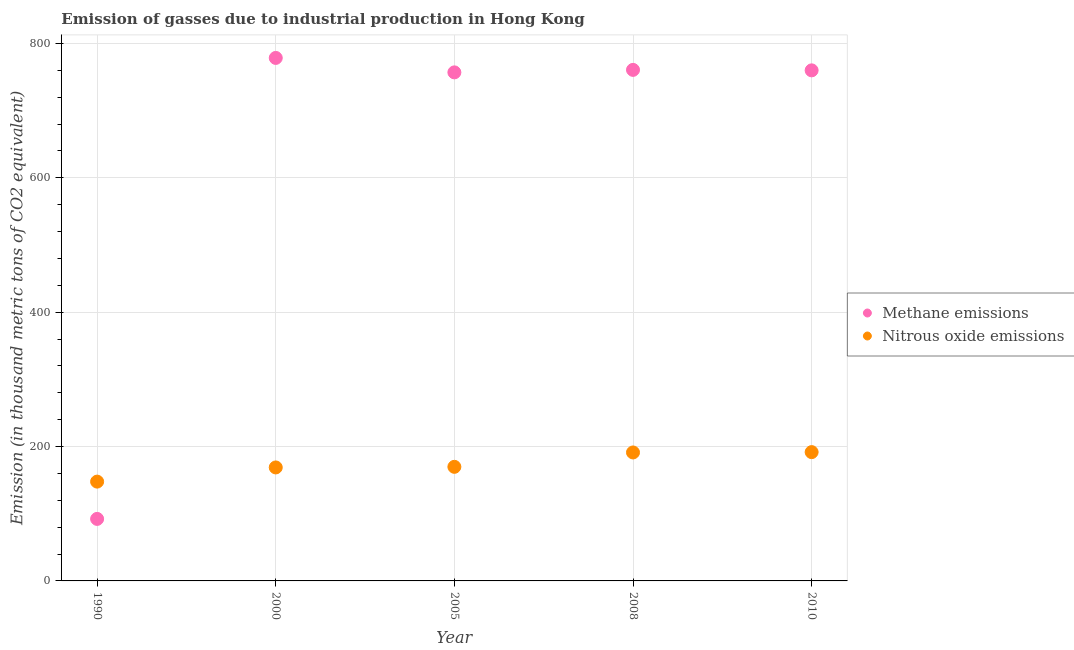What is the amount of nitrous oxide emissions in 2005?
Your answer should be compact. 169.8. Across all years, what is the maximum amount of nitrous oxide emissions?
Keep it short and to the point. 191.7. Across all years, what is the minimum amount of nitrous oxide emissions?
Provide a succinct answer. 147.8. In which year was the amount of nitrous oxide emissions minimum?
Your answer should be very brief. 1990. What is the total amount of nitrous oxide emissions in the graph?
Make the answer very short. 869.4. What is the difference between the amount of methane emissions in 2005 and that in 2010?
Your answer should be compact. -3. What is the difference between the amount of nitrous oxide emissions in 1990 and the amount of methane emissions in 2008?
Keep it short and to the point. -612.8. What is the average amount of methane emissions per year?
Give a very brief answer. 629.62. In the year 2005, what is the difference between the amount of nitrous oxide emissions and amount of methane emissions?
Offer a very short reply. -587.1. What is the ratio of the amount of nitrous oxide emissions in 2005 to that in 2008?
Offer a very short reply. 0.89. Is the difference between the amount of methane emissions in 1990 and 2005 greater than the difference between the amount of nitrous oxide emissions in 1990 and 2005?
Provide a short and direct response. No. What is the difference between the highest and the lowest amount of methane emissions?
Your answer should be very brief. 686.1. In how many years, is the amount of nitrous oxide emissions greater than the average amount of nitrous oxide emissions taken over all years?
Your answer should be compact. 2. Does the amount of nitrous oxide emissions monotonically increase over the years?
Provide a short and direct response. Yes. Is the amount of methane emissions strictly greater than the amount of nitrous oxide emissions over the years?
Keep it short and to the point. No. Is the amount of nitrous oxide emissions strictly less than the amount of methane emissions over the years?
Provide a succinct answer. No. Are the values on the major ticks of Y-axis written in scientific E-notation?
Offer a very short reply. No. Does the graph contain any zero values?
Make the answer very short. No. How many legend labels are there?
Your response must be concise. 2. How are the legend labels stacked?
Make the answer very short. Vertical. What is the title of the graph?
Your response must be concise. Emission of gasses due to industrial production in Hong Kong. Does "Male labourers" appear as one of the legend labels in the graph?
Your response must be concise. No. What is the label or title of the X-axis?
Keep it short and to the point. Year. What is the label or title of the Y-axis?
Your answer should be compact. Emission (in thousand metric tons of CO2 equivalent). What is the Emission (in thousand metric tons of CO2 equivalent) in Methane emissions in 1990?
Offer a very short reply. 92.3. What is the Emission (in thousand metric tons of CO2 equivalent) of Nitrous oxide emissions in 1990?
Your answer should be very brief. 147.8. What is the Emission (in thousand metric tons of CO2 equivalent) of Methane emissions in 2000?
Provide a short and direct response. 778.4. What is the Emission (in thousand metric tons of CO2 equivalent) of Nitrous oxide emissions in 2000?
Your response must be concise. 168.9. What is the Emission (in thousand metric tons of CO2 equivalent) in Methane emissions in 2005?
Offer a terse response. 756.9. What is the Emission (in thousand metric tons of CO2 equivalent) in Nitrous oxide emissions in 2005?
Give a very brief answer. 169.8. What is the Emission (in thousand metric tons of CO2 equivalent) in Methane emissions in 2008?
Keep it short and to the point. 760.6. What is the Emission (in thousand metric tons of CO2 equivalent) in Nitrous oxide emissions in 2008?
Make the answer very short. 191.2. What is the Emission (in thousand metric tons of CO2 equivalent) in Methane emissions in 2010?
Make the answer very short. 759.9. What is the Emission (in thousand metric tons of CO2 equivalent) in Nitrous oxide emissions in 2010?
Make the answer very short. 191.7. Across all years, what is the maximum Emission (in thousand metric tons of CO2 equivalent) of Methane emissions?
Your answer should be compact. 778.4. Across all years, what is the maximum Emission (in thousand metric tons of CO2 equivalent) of Nitrous oxide emissions?
Give a very brief answer. 191.7. Across all years, what is the minimum Emission (in thousand metric tons of CO2 equivalent) in Methane emissions?
Give a very brief answer. 92.3. Across all years, what is the minimum Emission (in thousand metric tons of CO2 equivalent) of Nitrous oxide emissions?
Offer a terse response. 147.8. What is the total Emission (in thousand metric tons of CO2 equivalent) in Methane emissions in the graph?
Your answer should be very brief. 3148.1. What is the total Emission (in thousand metric tons of CO2 equivalent) in Nitrous oxide emissions in the graph?
Ensure brevity in your answer.  869.4. What is the difference between the Emission (in thousand metric tons of CO2 equivalent) of Methane emissions in 1990 and that in 2000?
Keep it short and to the point. -686.1. What is the difference between the Emission (in thousand metric tons of CO2 equivalent) of Nitrous oxide emissions in 1990 and that in 2000?
Offer a terse response. -21.1. What is the difference between the Emission (in thousand metric tons of CO2 equivalent) in Methane emissions in 1990 and that in 2005?
Offer a very short reply. -664.6. What is the difference between the Emission (in thousand metric tons of CO2 equivalent) in Methane emissions in 1990 and that in 2008?
Provide a short and direct response. -668.3. What is the difference between the Emission (in thousand metric tons of CO2 equivalent) in Nitrous oxide emissions in 1990 and that in 2008?
Keep it short and to the point. -43.4. What is the difference between the Emission (in thousand metric tons of CO2 equivalent) in Methane emissions in 1990 and that in 2010?
Your answer should be very brief. -667.6. What is the difference between the Emission (in thousand metric tons of CO2 equivalent) of Nitrous oxide emissions in 1990 and that in 2010?
Offer a very short reply. -43.9. What is the difference between the Emission (in thousand metric tons of CO2 equivalent) in Nitrous oxide emissions in 2000 and that in 2005?
Offer a very short reply. -0.9. What is the difference between the Emission (in thousand metric tons of CO2 equivalent) in Nitrous oxide emissions in 2000 and that in 2008?
Keep it short and to the point. -22.3. What is the difference between the Emission (in thousand metric tons of CO2 equivalent) in Methane emissions in 2000 and that in 2010?
Keep it short and to the point. 18.5. What is the difference between the Emission (in thousand metric tons of CO2 equivalent) of Nitrous oxide emissions in 2000 and that in 2010?
Make the answer very short. -22.8. What is the difference between the Emission (in thousand metric tons of CO2 equivalent) of Nitrous oxide emissions in 2005 and that in 2008?
Ensure brevity in your answer.  -21.4. What is the difference between the Emission (in thousand metric tons of CO2 equivalent) in Methane emissions in 2005 and that in 2010?
Provide a succinct answer. -3. What is the difference between the Emission (in thousand metric tons of CO2 equivalent) of Nitrous oxide emissions in 2005 and that in 2010?
Your answer should be compact. -21.9. What is the difference between the Emission (in thousand metric tons of CO2 equivalent) in Nitrous oxide emissions in 2008 and that in 2010?
Provide a short and direct response. -0.5. What is the difference between the Emission (in thousand metric tons of CO2 equivalent) in Methane emissions in 1990 and the Emission (in thousand metric tons of CO2 equivalent) in Nitrous oxide emissions in 2000?
Your answer should be very brief. -76.6. What is the difference between the Emission (in thousand metric tons of CO2 equivalent) in Methane emissions in 1990 and the Emission (in thousand metric tons of CO2 equivalent) in Nitrous oxide emissions in 2005?
Your answer should be very brief. -77.5. What is the difference between the Emission (in thousand metric tons of CO2 equivalent) in Methane emissions in 1990 and the Emission (in thousand metric tons of CO2 equivalent) in Nitrous oxide emissions in 2008?
Offer a terse response. -98.9. What is the difference between the Emission (in thousand metric tons of CO2 equivalent) of Methane emissions in 1990 and the Emission (in thousand metric tons of CO2 equivalent) of Nitrous oxide emissions in 2010?
Your response must be concise. -99.4. What is the difference between the Emission (in thousand metric tons of CO2 equivalent) in Methane emissions in 2000 and the Emission (in thousand metric tons of CO2 equivalent) in Nitrous oxide emissions in 2005?
Ensure brevity in your answer.  608.6. What is the difference between the Emission (in thousand metric tons of CO2 equivalent) of Methane emissions in 2000 and the Emission (in thousand metric tons of CO2 equivalent) of Nitrous oxide emissions in 2008?
Offer a very short reply. 587.2. What is the difference between the Emission (in thousand metric tons of CO2 equivalent) of Methane emissions in 2000 and the Emission (in thousand metric tons of CO2 equivalent) of Nitrous oxide emissions in 2010?
Provide a short and direct response. 586.7. What is the difference between the Emission (in thousand metric tons of CO2 equivalent) of Methane emissions in 2005 and the Emission (in thousand metric tons of CO2 equivalent) of Nitrous oxide emissions in 2008?
Offer a very short reply. 565.7. What is the difference between the Emission (in thousand metric tons of CO2 equivalent) in Methane emissions in 2005 and the Emission (in thousand metric tons of CO2 equivalent) in Nitrous oxide emissions in 2010?
Keep it short and to the point. 565.2. What is the difference between the Emission (in thousand metric tons of CO2 equivalent) of Methane emissions in 2008 and the Emission (in thousand metric tons of CO2 equivalent) of Nitrous oxide emissions in 2010?
Make the answer very short. 568.9. What is the average Emission (in thousand metric tons of CO2 equivalent) of Methane emissions per year?
Keep it short and to the point. 629.62. What is the average Emission (in thousand metric tons of CO2 equivalent) in Nitrous oxide emissions per year?
Offer a very short reply. 173.88. In the year 1990, what is the difference between the Emission (in thousand metric tons of CO2 equivalent) of Methane emissions and Emission (in thousand metric tons of CO2 equivalent) of Nitrous oxide emissions?
Your answer should be very brief. -55.5. In the year 2000, what is the difference between the Emission (in thousand metric tons of CO2 equivalent) of Methane emissions and Emission (in thousand metric tons of CO2 equivalent) of Nitrous oxide emissions?
Provide a short and direct response. 609.5. In the year 2005, what is the difference between the Emission (in thousand metric tons of CO2 equivalent) in Methane emissions and Emission (in thousand metric tons of CO2 equivalent) in Nitrous oxide emissions?
Provide a succinct answer. 587.1. In the year 2008, what is the difference between the Emission (in thousand metric tons of CO2 equivalent) of Methane emissions and Emission (in thousand metric tons of CO2 equivalent) of Nitrous oxide emissions?
Provide a short and direct response. 569.4. In the year 2010, what is the difference between the Emission (in thousand metric tons of CO2 equivalent) of Methane emissions and Emission (in thousand metric tons of CO2 equivalent) of Nitrous oxide emissions?
Your answer should be compact. 568.2. What is the ratio of the Emission (in thousand metric tons of CO2 equivalent) of Methane emissions in 1990 to that in 2000?
Provide a succinct answer. 0.12. What is the ratio of the Emission (in thousand metric tons of CO2 equivalent) of Nitrous oxide emissions in 1990 to that in 2000?
Make the answer very short. 0.88. What is the ratio of the Emission (in thousand metric tons of CO2 equivalent) in Methane emissions in 1990 to that in 2005?
Ensure brevity in your answer.  0.12. What is the ratio of the Emission (in thousand metric tons of CO2 equivalent) in Nitrous oxide emissions in 1990 to that in 2005?
Offer a terse response. 0.87. What is the ratio of the Emission (in thousand metric tons of CO2 equivalent) in Methane emissions in 1990 to that in 2008?
Ensure brevity in your answer.  0.12. What is the ratio of the Emission (in thousand metric tons of CO2 equivalent) in Nitrous oxide emissions in 1990 to that in 2008?
Make the answer very short. 0.77. What is the ratio of the Emission (in thousand metric tons of CO2 equivalent) in Methane emissions in 1990 to that in 2010?
Make the answer very short. 0.12. What is the ratio of the Emission (in thousand metric tons of CO2 equivalent) of Nitrous oxide emissions in 1990 to that in 2010?
Ensure brevity in your answer.  0.77. What is the ratio of the Emission (in thousand metric tons of CO2 equivalent) in Methane emissions in 2000 to that in 2005?
Keep it short and to the point. 1.03. What is the ratio of the Emission (in thousand metric tons of CO2 equivalent) of Nitrous oxide emissions in 2000 to that in 2005?
Keep it short and to the point. 0.99. What is the ratio of the Emission (in thousand metric tons of CO2 equivalent) of Methane emissions in 2000 to that in 2008?
Offer a terse response. 1.02. What is the ratio of the Emission (in thousand metric tons of CO2 equivalent) of Nitrous oxide emissions in 2000 to that in 2008?
Provide a short and direct response. 0.88. What is the ratio of the Emission (in thousand metric tons of CO2 equivalent) in Methane emissions in 2000 to that in 2010?
Make the answer very short. 1.02. What is the ratio of the Emission (in thousand metric tons of CO2 equivalent) in Nitrous oxide emissions in 2000 to that in 2010?
Give a very brief answer. 0.88. What is the ratio of the Emission (in thousand metric tons of CO2 equivalent) in Methane emissions in 2005 to that in 2008?
Your answer should be very brief. 1. What is the ratio of the Emission (in thousand metric tons of CO2 equivalent) in Nitrous oxide emissions in 2005 to that in 2008?
Your answer should be compact. 0.89. What is the ratio of the Emission (in thousand metric tons of CO2 equivalent) of Nitrous oxide emissions in 2005 to that in 2010?
Provide a short and direct response. 0.89. What is the ratio of the Emission (in thousand metric tons of CO2 equivalent) of Methane emissions in 2008 to that in 2010?
Make the answer very short. 1. What is the ratio of the Emission (in thousand metric tons of CO2 equivalent) in Nitrous oxide emissions in 2008 to that in 2010?
Offer a very short reply. 1. What is the difference between the highest and the second highest Emission (in thousand metric tons of CO2 equivalent) of Nitrous oxide emissions?
Offer a very short reply. 0.5. What is the difference between the highest and the lowest Emission (in thousand metric tons of CO2 equivalent) in Methane emissions?
Your response must be concise. 686.1. What is the difference between the highest and the lowest Emission (in thousand metric tons of CO2 equivalent) in Nitrous oxide emissions?
Your answer should be very brief. 43.9. 